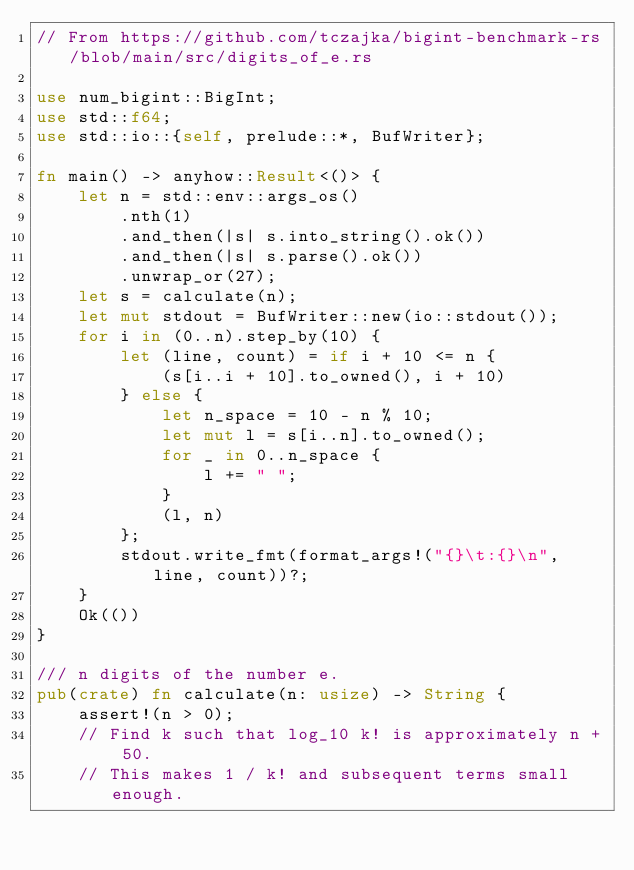Convert code to text. <code><loc_0><loc_0><loc_500><loc_500><_Rust_>// From https://github.com/tczajka/bigint-benchmark-rs/blob/main/src/digits_of_e.rs

use num_bigint::BigInt;
use std::f64;
use std::io::{self, prelude::*, BufWriter};

fn main() -> anyhow::Result<()> {
    let n = std::env::args_os()
        .nth(1)
        .and_then(|s| s.into_string().ok())
        .and_then(|s| s.parse().ok())
        .unwrap_or(27);
    let s = calculate(n);
    let mut stdout = BufWriter::new(io::stdout());
    for i in (0..n).step_by(10) {
        let (line, count) = if i + 10 <= n {
            (s[i..i + 10].to_owned(), i + 10)
        } else {
            let n_space = 10 - n % 10;
            let mut l = s[i..n].to_owned();
            for _ in 0..n_space {
                l += " ";
            }
            (l, n)
        };
        stdout.write_fmt(format_args!("{}\t:{}\n", line, count))?;
    }
    Ok(())
}

/// n digits of the number e.
pub(crate) fn calculate(n: usize) -> String {
    assert!(n > 0);
    // Find k such that log_10 k! is approximately n + 50.
    // This makes 1 / k! and subsequent terms small enough.</code> 